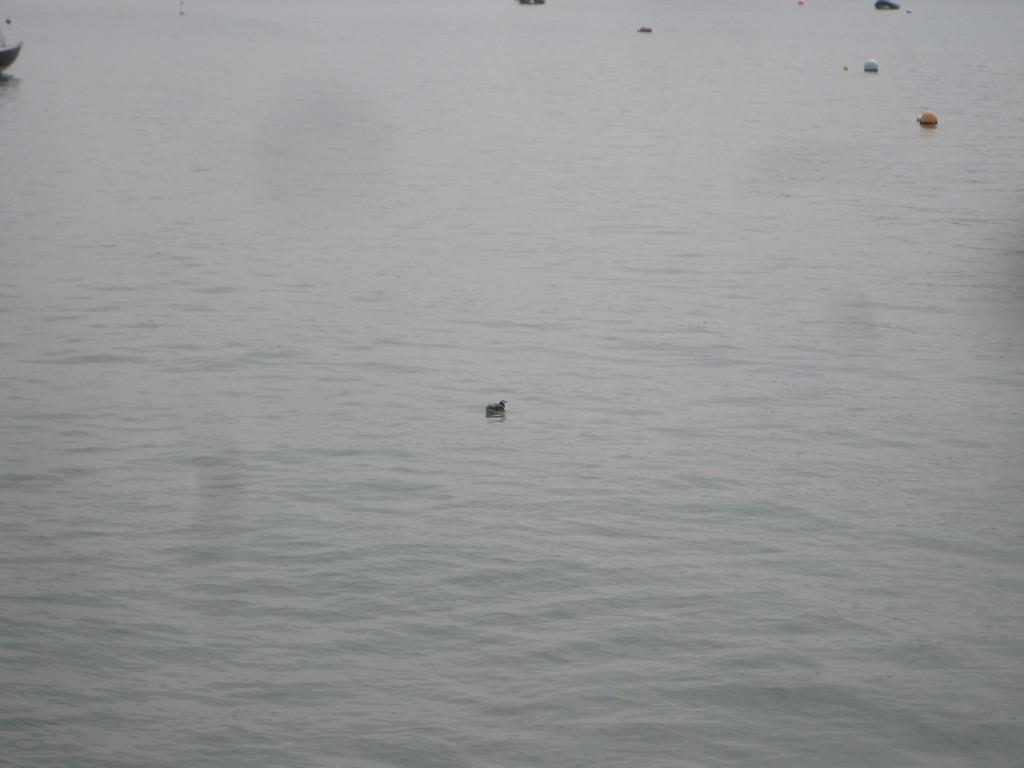What is the primary element visible in the image? There is water in the image. Are there any objects floating or placed on the water? Yes, there are objects on the water. What type of crib is visible in the image? There is no crib present in the image; it features water and objects on the water. What class is being taught in the image? There is no class or teaching activity depicted in the image. 